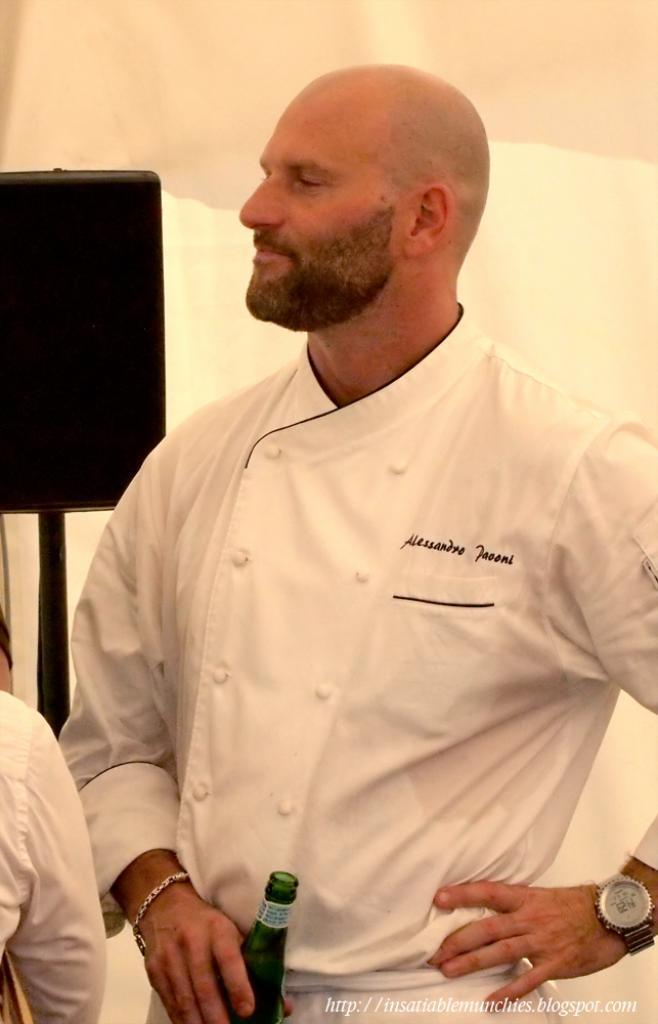Who is present in the image? There is a man in the image. What is the man holding in his hand? The man is holding a bottle in his hand. What accessories is the man wearing? The man is wearing a bracelet and a watch. What is the position of the road in the image? There is no road present in the image; it features a man holding a bottle and wearing a bracelet and a watch. 